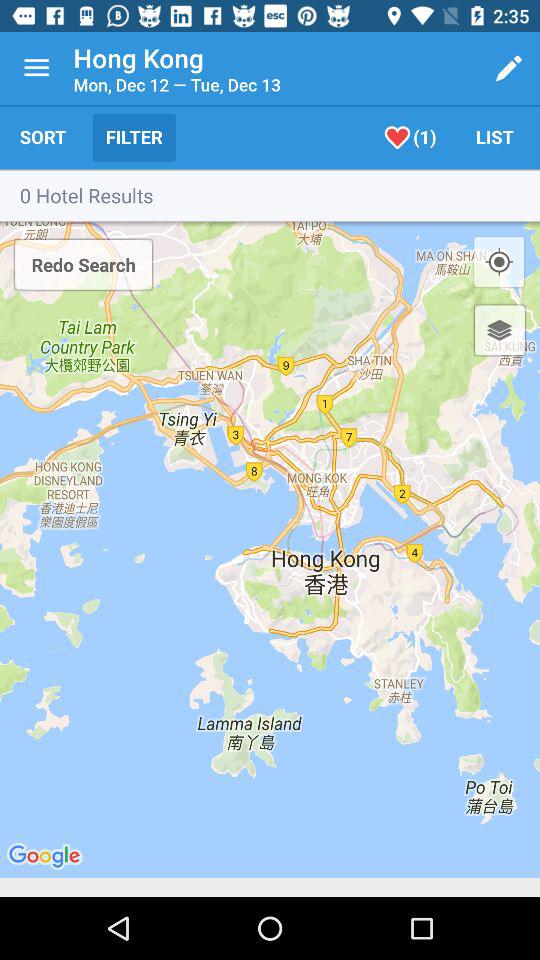What day is it on Dec 12? The day is Monday. 